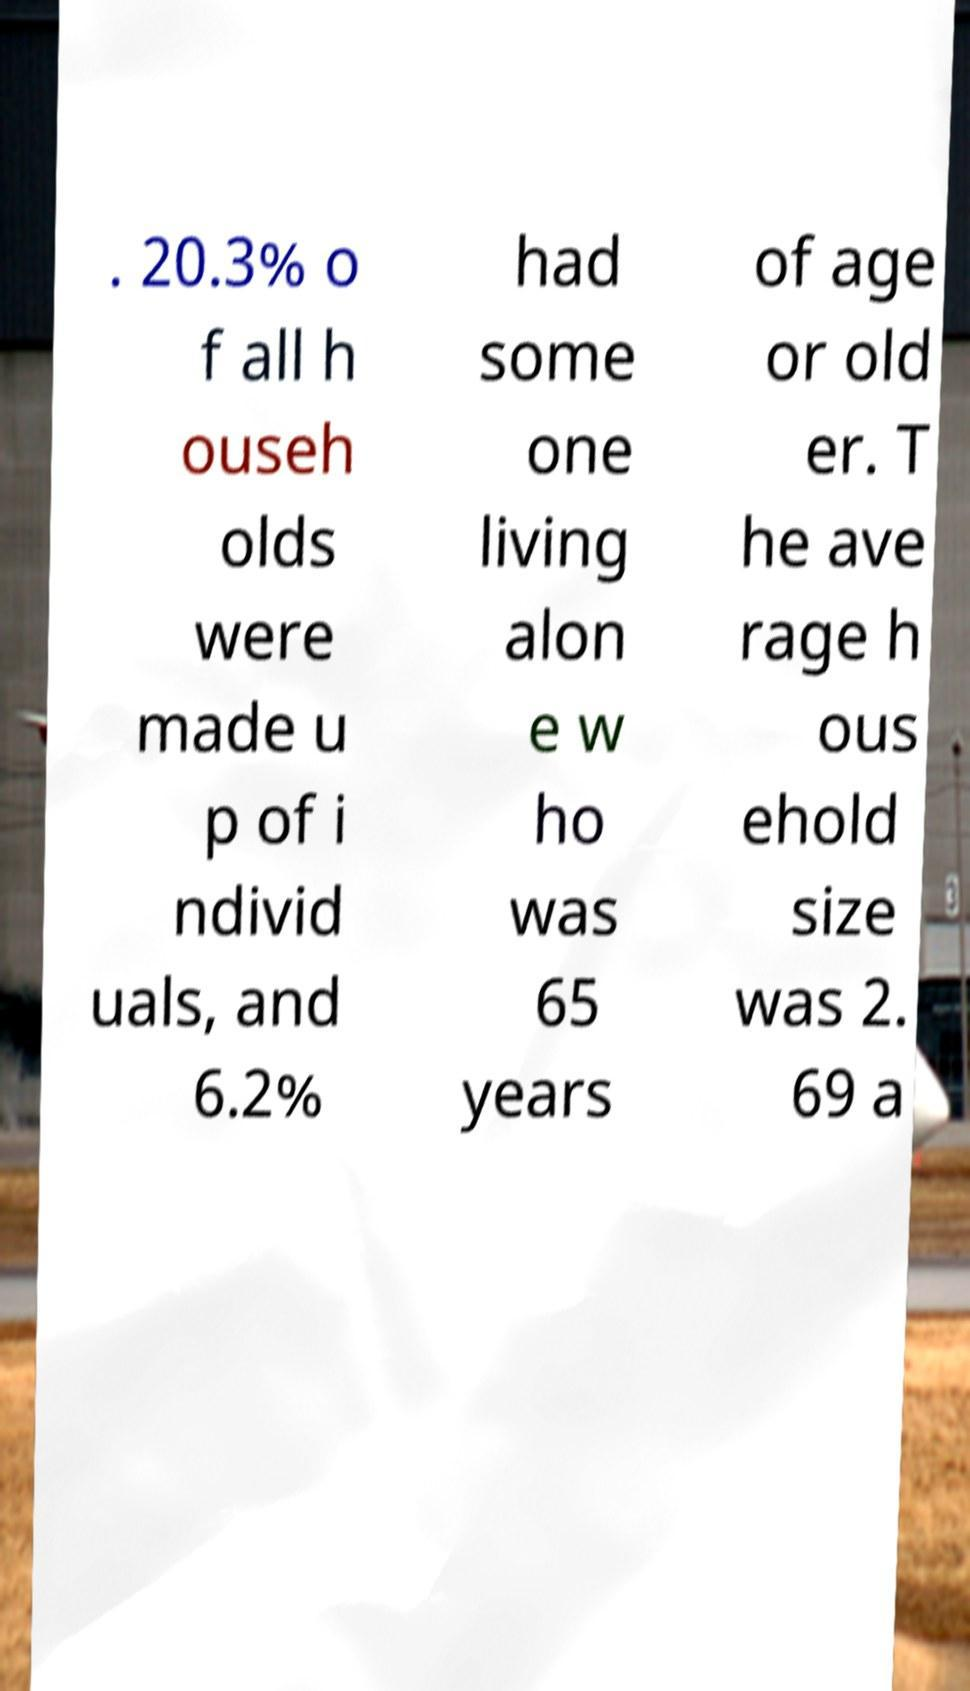For documentation purposes, I need the text within this image transcribed. Could you provide that? . 20.3% o f all h ouseh olds were made u p of i ndivid uals, and 6.2% had some one living alon e w ho was 65 years of age or old er. T he ave rage h ous ehold size was 2. 69 a 